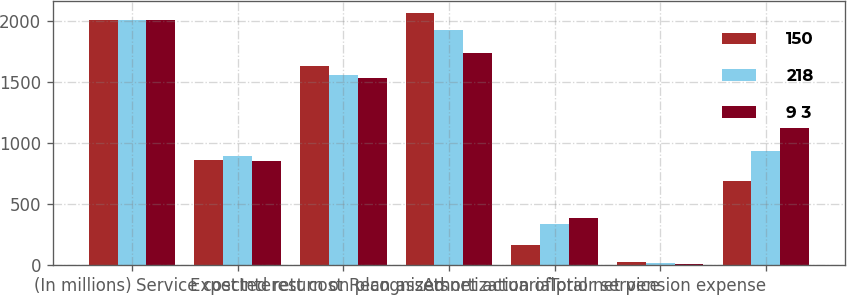Convert chart. <chart><loc_0><loc_0><loc_500><loc_500><stacked_bar_chart><ecel><fcel>(In millions)<fcel>Service cost<fcel>Interest cost<fcel>Expected return on plan assets<fcel>Recognized net actuarial<fcel>Amortization of prior service<fcel>Total net pension expense<nl><fcel>150<fcel>2007<fcel>862<fcel>1631<fcel>2063<fcel>168<fcel>24<fcel>687<nl><fcel>218<fcel>2006<fcel>896<fcel>1557<fcel>1930<fcel>335<fcel>23<fcel>938<nl><fcel>9 3<fcel>2005<fcel>852<fcel>1535<fcel>1740<fcel>392<fcel>14<fcel>1124<nl></chart> 